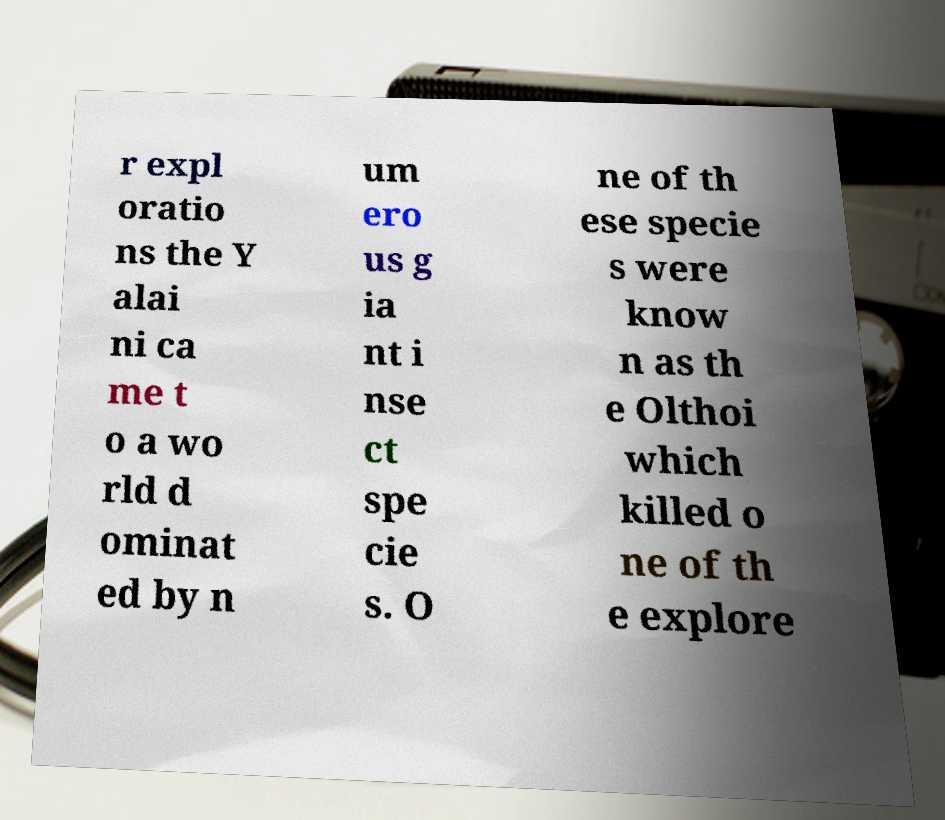Please identify and transcribe the text found in this image. r expl oratio ns the Y alai ni ca me t o a wo rld d ominat ed by n um ero us g ia nt i nse ct spe cie s. O ne of th ese specie s were know n as th e Olthoi which killed o ne of th e explore 